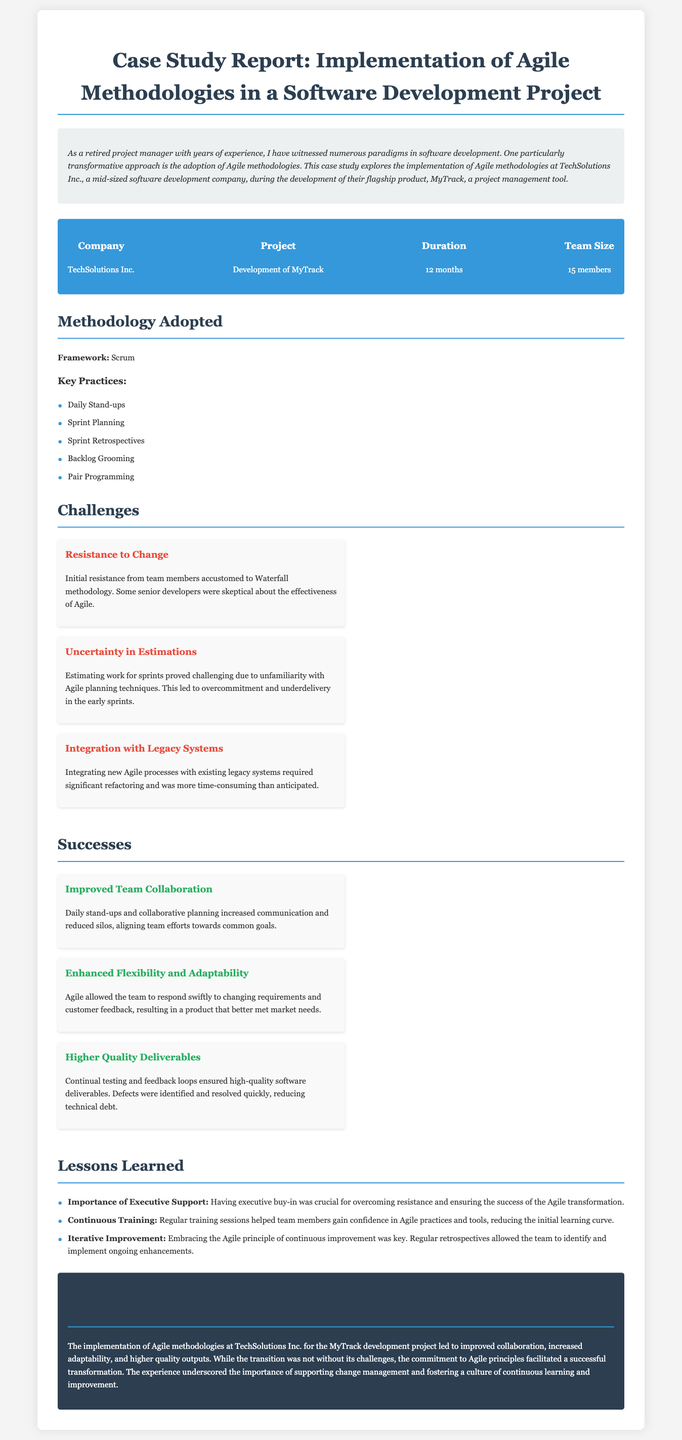What is the name of the company discussed in the case study? The company discussed is TechSolutions Inc.
Answer: TechSolutions Inc What was the duration of the project? The duration of the project is specified in the document as lasting 12 months.
Answer: 12 months What methodology framework was adopted for the project? The document specifies that the framework adopted was Scrum.
Answer: Scrum What is one challenge faced during the Agile implementation? Resistance to Change is highlighted as a challenge faced by the team.
Answer: Resistance to Change What was one of the successes of implementing Agile methodologies? Improved Team Collaboration is listed as a success achieved during the project.
Answer: Improved Team Collaboration What is a key lesson learned from the implementation process? The document mentions the Importance of Executive Support as a key lesson learned.
Answer: Importance of Executive Support How many team members were involved in the project? The document states that the team size was 15 members.
Answer: 15 members What practice involves daily communication among team members? Daily Stand-ups is noted as a key practice involving daily communication.
Answer: Daily Stand-ups Which aspect of project management improved due to Agile practices? Higher Quality Deliverables is highlighted as an aspect that improved.
Answer: Higher Quality Deliverables 